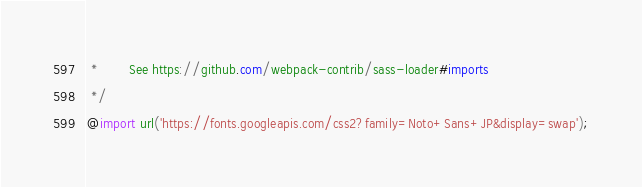Convert code to text. <code><loc_0><loc_0><loc_500><loc_500><_CSS_> *        See https://github.com/webpack-contrib/sass-loader#imports
 */
@import url('https://fonts.googleapis.com/css2?family=Noto+Sans+JP&display=swap');
</code> 